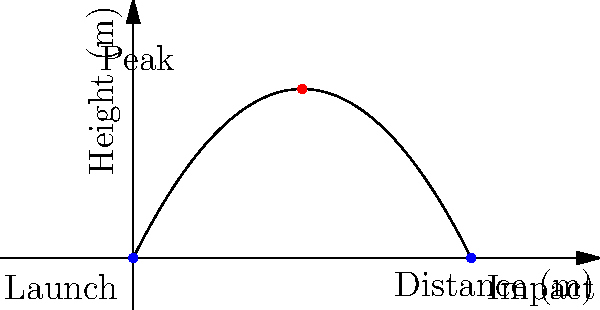In a medieval siege, a catapult launches a projectile with a trajectory modeled by the polynomial equation $h(x) = -0.05x^2 + 2x$, where $h$ is the height in meters and $x$ is the horizontal distance in meters. Given this information and the graph, determine the total horizontal distance the projectile travels before hitting the ground. To find the total horizontal distance, we need to determine where the projectile hits the ground, which occurs when the height $h(x)$ is zero. Let's solve this step-by-step:

1) Set the equation equal to zero:
   $h(x) = -0.05x^2 + 2x = 0$

2) Factor out x:
   $x(-0.05x + 2) = 0$

3) Solve for x:
   $x = 0$ or $-0.05x + 2 = 0$
   
   For the second equation:
   $-0.05x = -2$
   $x = 40$

4) Interpret the results:
   $x = 0$ represents the launch point
   $x = 40$ represents the impact point

5) The total horizontal distance is the difference between these points:
   $40 - 0 = 40$ meters

This result aligns with the graph, where we can see the projectile launching from (0,0) and hitting the ground at (40,0).
Answer: 40 meters 